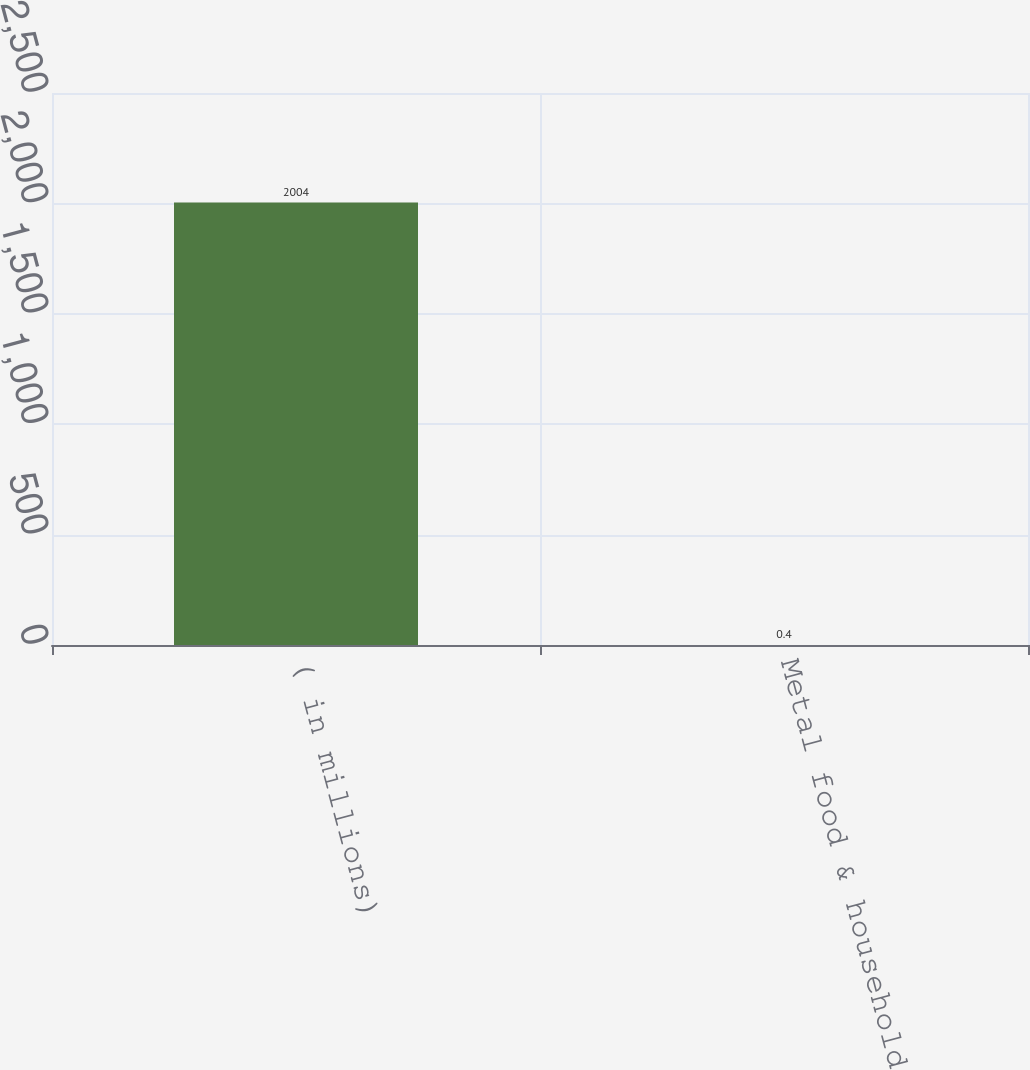<chart> <loc_0><loc_0><loc_500><loc_500><bar_chart><fcel>( in millions)<fcel>Metal food & household<nl><fcel>2004<fcel>0.4<nl></chart> 